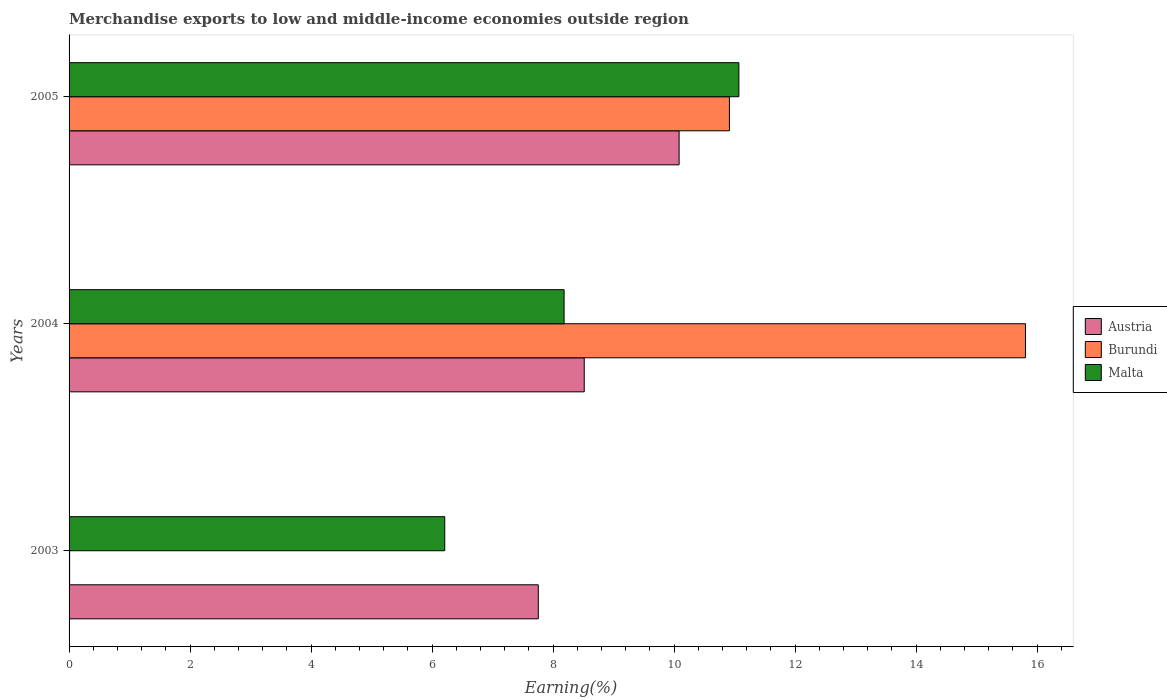How many different coloured bars are there?
Make the answer very short. 3. Are the number of bars per tick equal to the number of legend labels?
Give a very brief answer. Yes. Are the number of bars on each tick of the Y-axis equal?
Your answer should be very brief. Yes. How many bars are there on the 2nd tick from the top?
Your answer should be compact. 3. How many bars are there on the 2nd tick from the bottom?
Your response must be concise. 3. What is the percentage of amount earned from merchandise exports in Malta in 2004?
Offer a very short reply. 8.18. Across all years, what is the maximum percentage of amount earned from merchandise exports in Burundi?
Provide a succinct answer. 15.81. Across all years, what is the minimum percentage of amount earned from merchandise exports in Austria?
Make the answer very short. 7.76. In which year was the percentage of amount earned from merchandise exports in Burundi minimum?
Make the answer very short. 2003. What is the total percentage of amount earned from merchandise exports in Austria in the graph?
Ensure brevity in your answer.  26.35. What is the difference between the percentage of amount earned from merchandise exports in Malta in 2004 and that in 2005?
Provide a succinct answer. -2.89. What is the difference between the percentage of amount earned from merchandise exports in Malta in 2004 and the percentage of amount earned from merchandise exports in Burundi in 2003?
Ensure brevity in your answer.  8.17. What is the average percentage of amount earned from merchandise exports in Malta per year?
Ensure brevity in your answer.  8.49. In the year 2003, what is the difference between the percentage of amount earned from merchandise exports in Burundi and percentage of amount earned from merchandise exports in Malta?
Your answer should be compact. -6.2. What is the ratio of the percentage of amount earned from merchandise exports in Austria in 2003 to that in 2004?
Give a very brief answer. 0.91. Is the difference between the percentage of amount earned from merchandise exports in Burundi in 2004 and 2005 greater than the difference between the percentage of amount earned from merchandise exports in Malta in 2004 and 2005?
Offer a terse response. Yes. What is the difference between the highest and the second highest percentage of amount earned from merchandise exports in Malta?
Your response must be concise. 2.89. What is the difference between the highest and the lowest percentage of amount earned from merchandise exports in Austria?
Make the answer very short. 2.33. Is the sum of the percentage of amount earned from merchandise exports in Burundi in 2004 and 2005 greater than the maximum percentage of amount earned from merchandise exports in Malta across all years?
Your answer should be compact. Yes. What does the 1st bar from the top in 2004 represents?
Provide a succinct answer. Malta. What does the 2nd bar from the bottom in 2004 represents?
Provide a succinct answer. Burundi. How many bars are there?
Keep it short and to the point. 9. How many years are there in the graph?
Your response must be concise. 3. What is the difference between two consecutive major ticks on the X-axis?
Offer a very short reply. 2. Where does the legend appear in the graph?
Your response must be concise. Center right. How are the legend labels stacked?
Your answer should be very brief. Vertical. What is the title of the graph?
Offer a terse response. Merchandise exports to low and middle-income economies outside region. What is the label or title of the X-axis?
Provide a short and direct response. Earning(%). What is the label or title of the Y-axis?
Your answer should be compact. Years. What is the Earning(%) in Austria in 2003?
Make the answer very short. 7.76. What is the Earning(%) in Burundi in 2003?
Offer a very short reply. 0.01. What is the Earning(%) in Malta in 2003?
Make the answer very short. 6.21. What is the Earning(%) of Austria in 2004?
Provide a succinct answer. 8.51. What is the Earning(%) in Burundi in 2004?
Give a very brief answer. 15.81. What is the Earning(%) of Malta in 2004?
Your response must be concise. 8.18. What is the Earning(%) in Austria in 2005?
Make the answer very short. 10.08. What is the Earning(%) in Burundi in 2005?
Offer a terse response. 10.91. What is the Earning(%) of Malta in 2005?
Ensure brevity in your answer.  11.07. Across all years, what is the maximum Earning(%) of Austria?
Your answer should be compact. 10.08. Across all years, what is the maximum Earning(%) of Burundi?
Offer a very short reply. 15.81. Across all years, what is the maximum Earning(%) in Malta?
Provide a succinct answer. 11.07. Across all years, what is the minimum Earning(%) of Austria?
Your answer should be compact. 7.76. Across all years, what is the minimum Earning(%) in Burundi?
Offer a very short reply. 0.01. Across all years, what is the minimum Earning(%) in Malta?
Keep it short and to the point. 6.21. What is the total Earning(%) of Austria in the graph?
Your answer should be compact. 26.35. What is the total Earning(%) of Burundi in the graph?
Give a very brief answer. 26.73. What is the total Earning(%) of Malta in the graph?
Provide a short and direct response. 25.46. What is the difference between the Earning(%) of Austria in 2003 and that in 2004?
Make the answer very short. -0.76. What is the difference between the Earning(%) in Burundi in 2003 and that in 2004?
Offer a terse response. -15.8. What is the difference between the Earning(%) in Malta in 2003 and that in 2004?
Your answer should be very brief. -1.97. What is the difference between the Earning(%) in Austria in 2003 and that in 2005?
Provide a succinct answer. -2.33. What is the difference between the Earning(%) in Burundi in 2003 and that in 2005?
Give a very brief answer. -10.9. What is the difference between the Earning(%) in Malta in 2003 and that in 2005?
Give a very brief answer. -4.86. What is the difference between the Earning(%) in Austria in 2004 and that in 2005?
Keep it short and to the point. -1.57. What is the difference between the Earning(%) in Burundi in 2004 and that in 2005?
Your answer should be very brief. 4.89. What is the difference between the Earning(%) of Malta in 2004 and that in 2005?
Offer a terse response. -2.89. What is the difference between the Earning(%) in Austria in 2003 and the Earning(%) in Burundi in 2004?
Your answer should be very brief. -8.05. What is the difference between the Earning(%) in Austria in 2003 and the Earning(%) in Malta in 2004?
Provide a succinct answer. -0.43. What is the difference between the Earning(%) of Burundi in 2003 and the Earning(%) of Malta in 2004?
Your answer should be very brief. -8.17. What is the difference between the Earning(%) of Austria in 2003 and the Earning(%) of Burundi in 2005?
Ensure brevity in your answer.  -3.16. What is the difference between the Earning(%) of Austria in 2003 and the Earning(%) of Malta in 2005?
Offer a very short reply. -3.32. What is the difference between the Earning(%) of Burundi in 2003 and the Earning(%) of Malta in 2005?
Offer a very short reply. -11.06. What is the difference between the Earning(%) of Austria in 2004 and the Earning(%) of Burundi in 2005?
Provide a short and direct response. -2.4. What is the difference between the Earning(%) in Austria in 2004 and the Earning(%) in Malta in 2005?
Your response must be concise. -2.56. What is the difference between the Earning(%) of Burundi in 2004 and the Earning(%) of Malta in 2005?
Your answer should be very brief. 4.74. What is the average Earning(%) of Austria per year?
Make the answer very short. 8.78. What is the average Earning(%) in Burundi per year?
Offer a very short reply. 8.91. What is the average Earning(%) in Malta per year?
Your answer should be very brief. 8.49. In the year 2003, what is the difference between the Earning(%) of Austria and Earning(%) of Burundi?
Keep it short and to the point. 7.75. In the year 2003, what is the difference between the Earning(%) in Austria and Earning(%) in Malta?
Your response must be concise. 1.55. In the year 2004, what is the difference between the Earning(%) of Austria and Earning(%) of Burundi?
Your answer should be compact. -7.29. In the year 2004, what is the difference between the Earning(%) of Austria and Earning(%) of Malta?
Keep it short and to the point. 0.33. In the year 2004, what is the difference between the Earning(%) in Burundi and Earning(%) in Malta?
Keep it short and to the point. 7.63. In the year 2005, what is the difference between the Earning(%) in Austria and Earning(%) in Burundi?
Provide a short and direct response. -0.83. In the year 2005, what is the difference between the Earning(%) in Austria and Earning(%) in Malta?
Give a very brief answer. -0.99. In the year 2005, what is the difference between the Earning(%) of Burundi and Earning(%) of Malta?
Give a very brief answer. -0.16. What is the ratio of the Earning(%) in Austria in 2003 to that in 2004?
Provide a short and direct response. 0.91. What is the ratio of the Earning(%) of Burundi in 2003 to that in 2004?
Make the answer very short. 0. What is the ratio of the Earning(%) in Malta in 2003 to that in 2004?
Your answer should be very brief. 0.76. What is the ratio of the Earning(%) in Austria in 2003 to that in 2005?
Keep it short and to the point. 0.77. What is the ratio of the Earning(%) of Burundi in 2003 to that in 2005?
Your answer should be compact. 0. What is the ratio of the Earning(%) of Malta in 2003 to that in 2005?
Provide a succinct answer. 0.56. What is the ratio of the Earning(%) in Austria in 2004 to that in 2005?
Give a very brief answer. 0.84. What is the ratio of the Earning(%) in Burundi in 2004 to that in 2005?
Give a very brief answer. 1.45. What is the ratio of the Earning(%) of Malta in 2004 to that in 2005?
Your answer should be very brief. 0.74. What is the difference between the highest and the second highest Earning(%) in Austria?
Offer a very short reply. 1.57. What is the difference between the highest and the second highest Earning(%) of Burundi?
Provide a succinct answer. 4.89. What is the difference between the highest and the second highest Earning(%) of Malta?
Your response must be concise. 2.89. What is the difference between the highest and the lowest Earning(%) in Austria?
Your response must be concise. 2.33. What is the difference between the highest and the lowest Earning(%) in Burundi?
Offer a terse response. 15.8. What is the difference between the highest and the lowest Earning(%) of Malta?
Give a very brief answer. 4.86. 